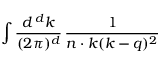Convert formula to latex. <formula><loc_0><loc_0><loc_500><loc_500>\int { \frac { d ^ { \, d } k } { ( 2 \pi ) ^ { d } } } \, { \frac { 1 } { n \cdot k ( k - q ) ^ { 2 } } }</formula> 